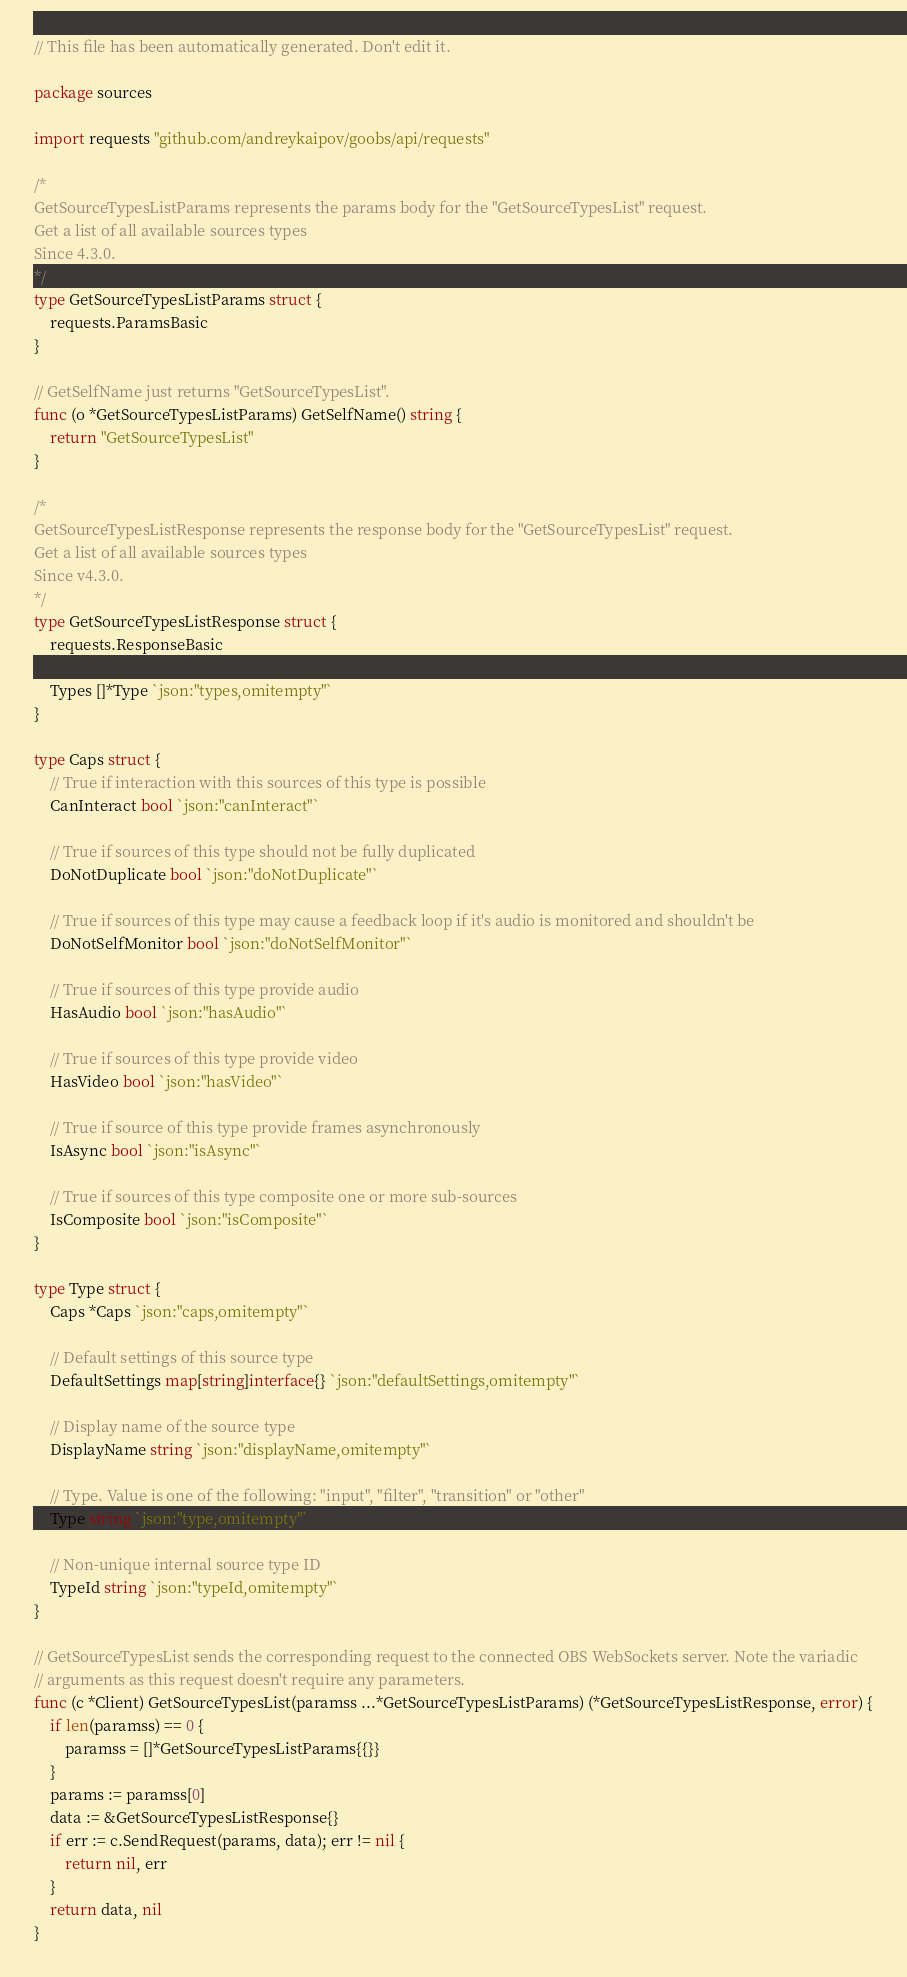Convert code to text. <code><loc_0><loc_0><loc_500><loc_500><_Go_>// This file has been automatically generated. Don't edit it.

package sources

import requests "github.com/andreykaipov/goobs/api/requests"

/*
GetSourceTypesListParams represents the params body for the "GetSourceTypesList" request.
Get a list of all available sources types
Since 4.3.0.
*/
type GetSourceTypesListParams struct {
	requests.ParamsBasic
}

// GetSelfName just returns "GetSourceTypesList".
func (o *GetSourceTypesListParams) GetSelfName() string {
	return "GetSourceTypesList"
}

/*
GetSourceTypesListResponse represents the response body for the "GetSourceTypesList" request.
Get a list of all available sources types
Since v4.3.0.
*/
type GetSourceTypesListResponse struct {
	requests.ResponseBasic

	Types []*Type `json:"types,omitempty"`
}

type Caps struct {
	// True if interaction with this sources of this type is possible
	CanInteract bool `json:"canInteract"`

	// True if sources of this type should not be fully duplicated
	DoNotDuplicate bool `json:"doNotDuplicate"`

	// True if sources of this type may cause a feedback loop if it's audio is monitored and shouldn't be
	DoNotSelfMonitor bool `json:"doNotSelfMonitor"`

	// True if sources of this type provide audio
	HasAudio bool `json:"hasAudio"`

	// True if sources of this type provide video
	HasVideo bool `json:"hasVideo"`

	// True if source of this type provide frames asynchronously
	IsAsync bool `json:"isAsync"`

	// True if sources of this type composite one or more sub-sources
	IsComposite bool `json:"isComposite"`
}

type Type struct {
	Caps *Caps `json:"caps,omitempty"`

	// Default settings of this source type
	DefaultSettings map[string]interface{} `json:"defaultSettings,omitempty"`

	// Display name of the source type
	DisplayName string `json:"displayName,omitempty"`

	// Type. Value is one of the following: "input", "filter", "transition" or "other"
	Type string `json:"type,omitempty"`

	// Non-unique internal source type ID
	TypeId string `json:"typeId,omitempty"`
}

// GetSourceTypesList sends the corresponding request to the connected OBS WebSockets server. Note the variadic
// arguments as this request doesn't require any parameters.
func (c *Client) GetSourceTypesList(paramss ...*GetSourceTypesListParams) (*GetSourceTypesListResponse, error) {
	if len(paramss) == 0 {
		paramss = []*GetSourceTypesListParams{{}}
	}
	params := paramss[0]
	data := &GetSourceTypesListResponse{}
	if err := c.SendRequest(params, data); err != nil {
		return nil, err
	}
	return data, nil
}
</code> 